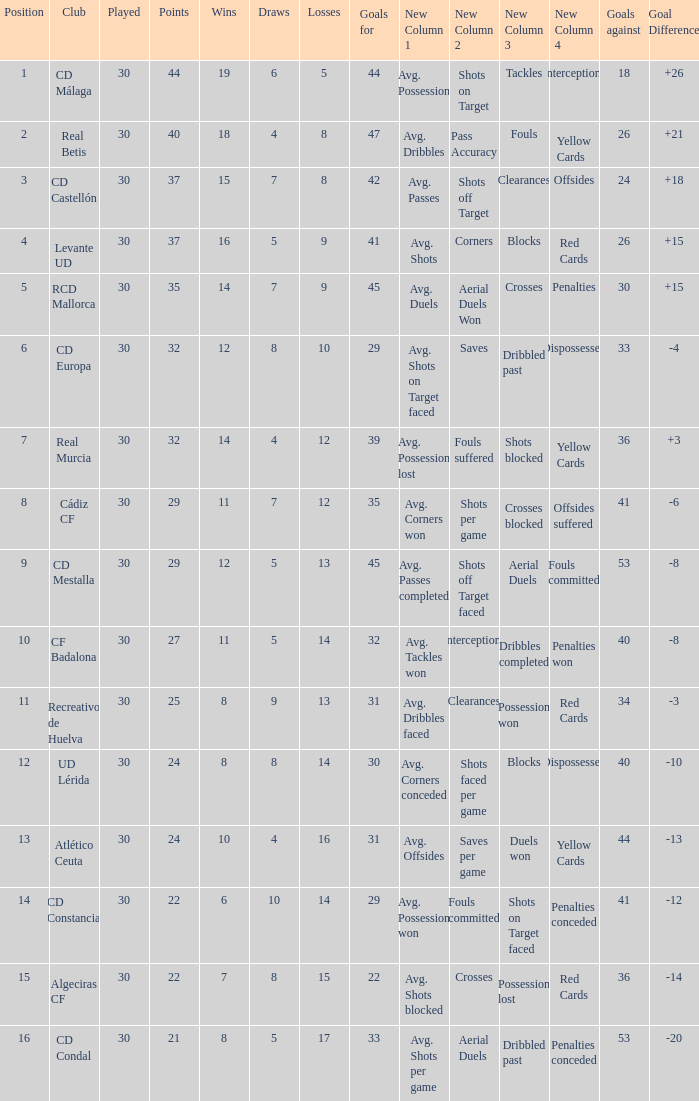What is the wins number when the points were smaller than 27, and goals against was 41? 6.0. 